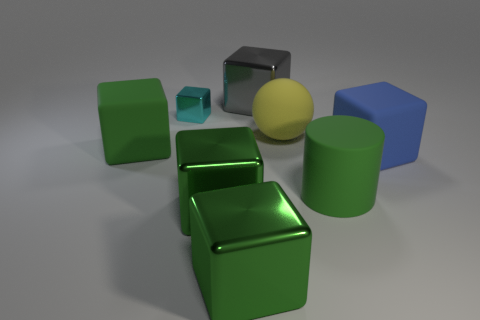Subtract all red cylinders. How many green blocks are left? 3 Subtract all large gray blocks. How many blocks are left? 5 Subtract all cyan cubes. How many cubes are left? 5 Subtract all purple cubes. Subtract all blue spheres. How many cubes are left? 6 Add 1 tiny brown blocks. How many objects exist? 9 Subtract all cubes. How many objects are left? 2 Add 6 big purple rubber cylinders. How many big purple rubber cylinders exist? 6 Subtract 2 green cubes. How many objects are left? 6 Subtract all small metal things. Subtract all large gray metallic blocks. How many objects are left? 6 Add 1 big things. How many big things are left? 8 